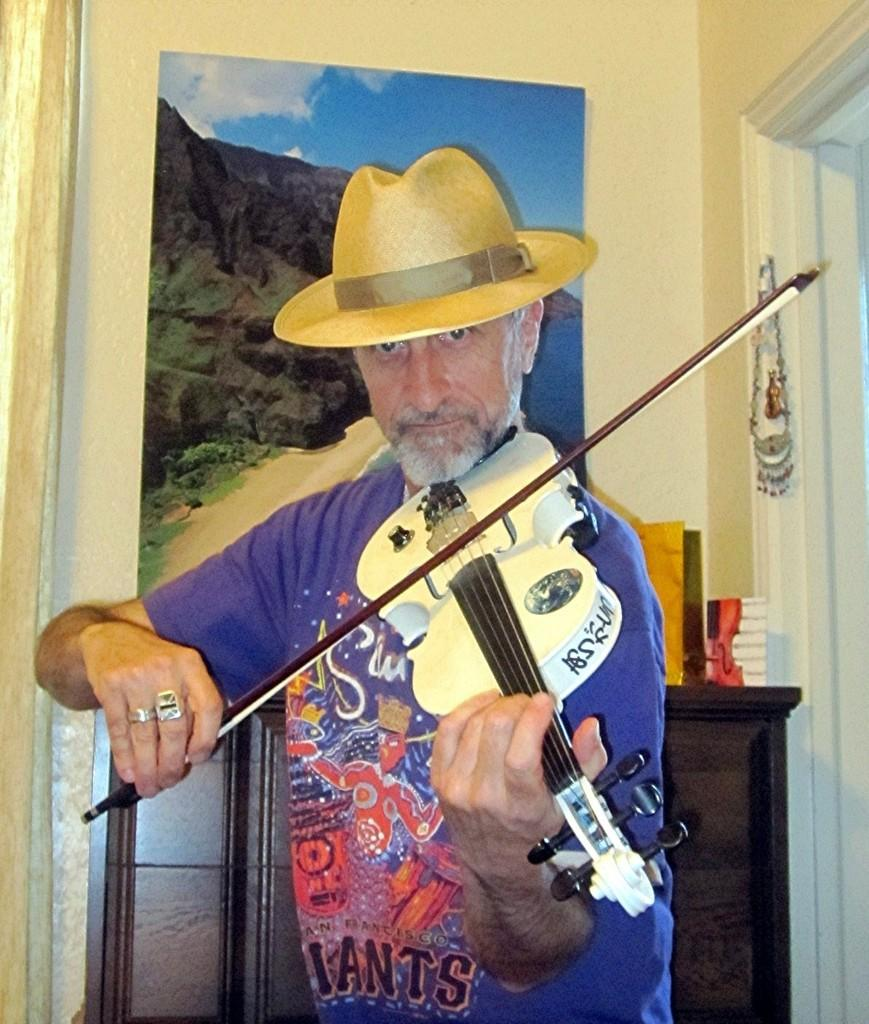What is there is a man in the image, what is he doing? The man in the image is standing and playing a violin. Can you describe the man's position in the image? The man is standing while playing the violin. What can be seen in the background of the image? There is a frame attached to a wall and a table in the background. What type of knee injury is the man experiencing in the image? There is no indication of a knee injury in the image; the man is standing and playing a violin without any visible issues. 